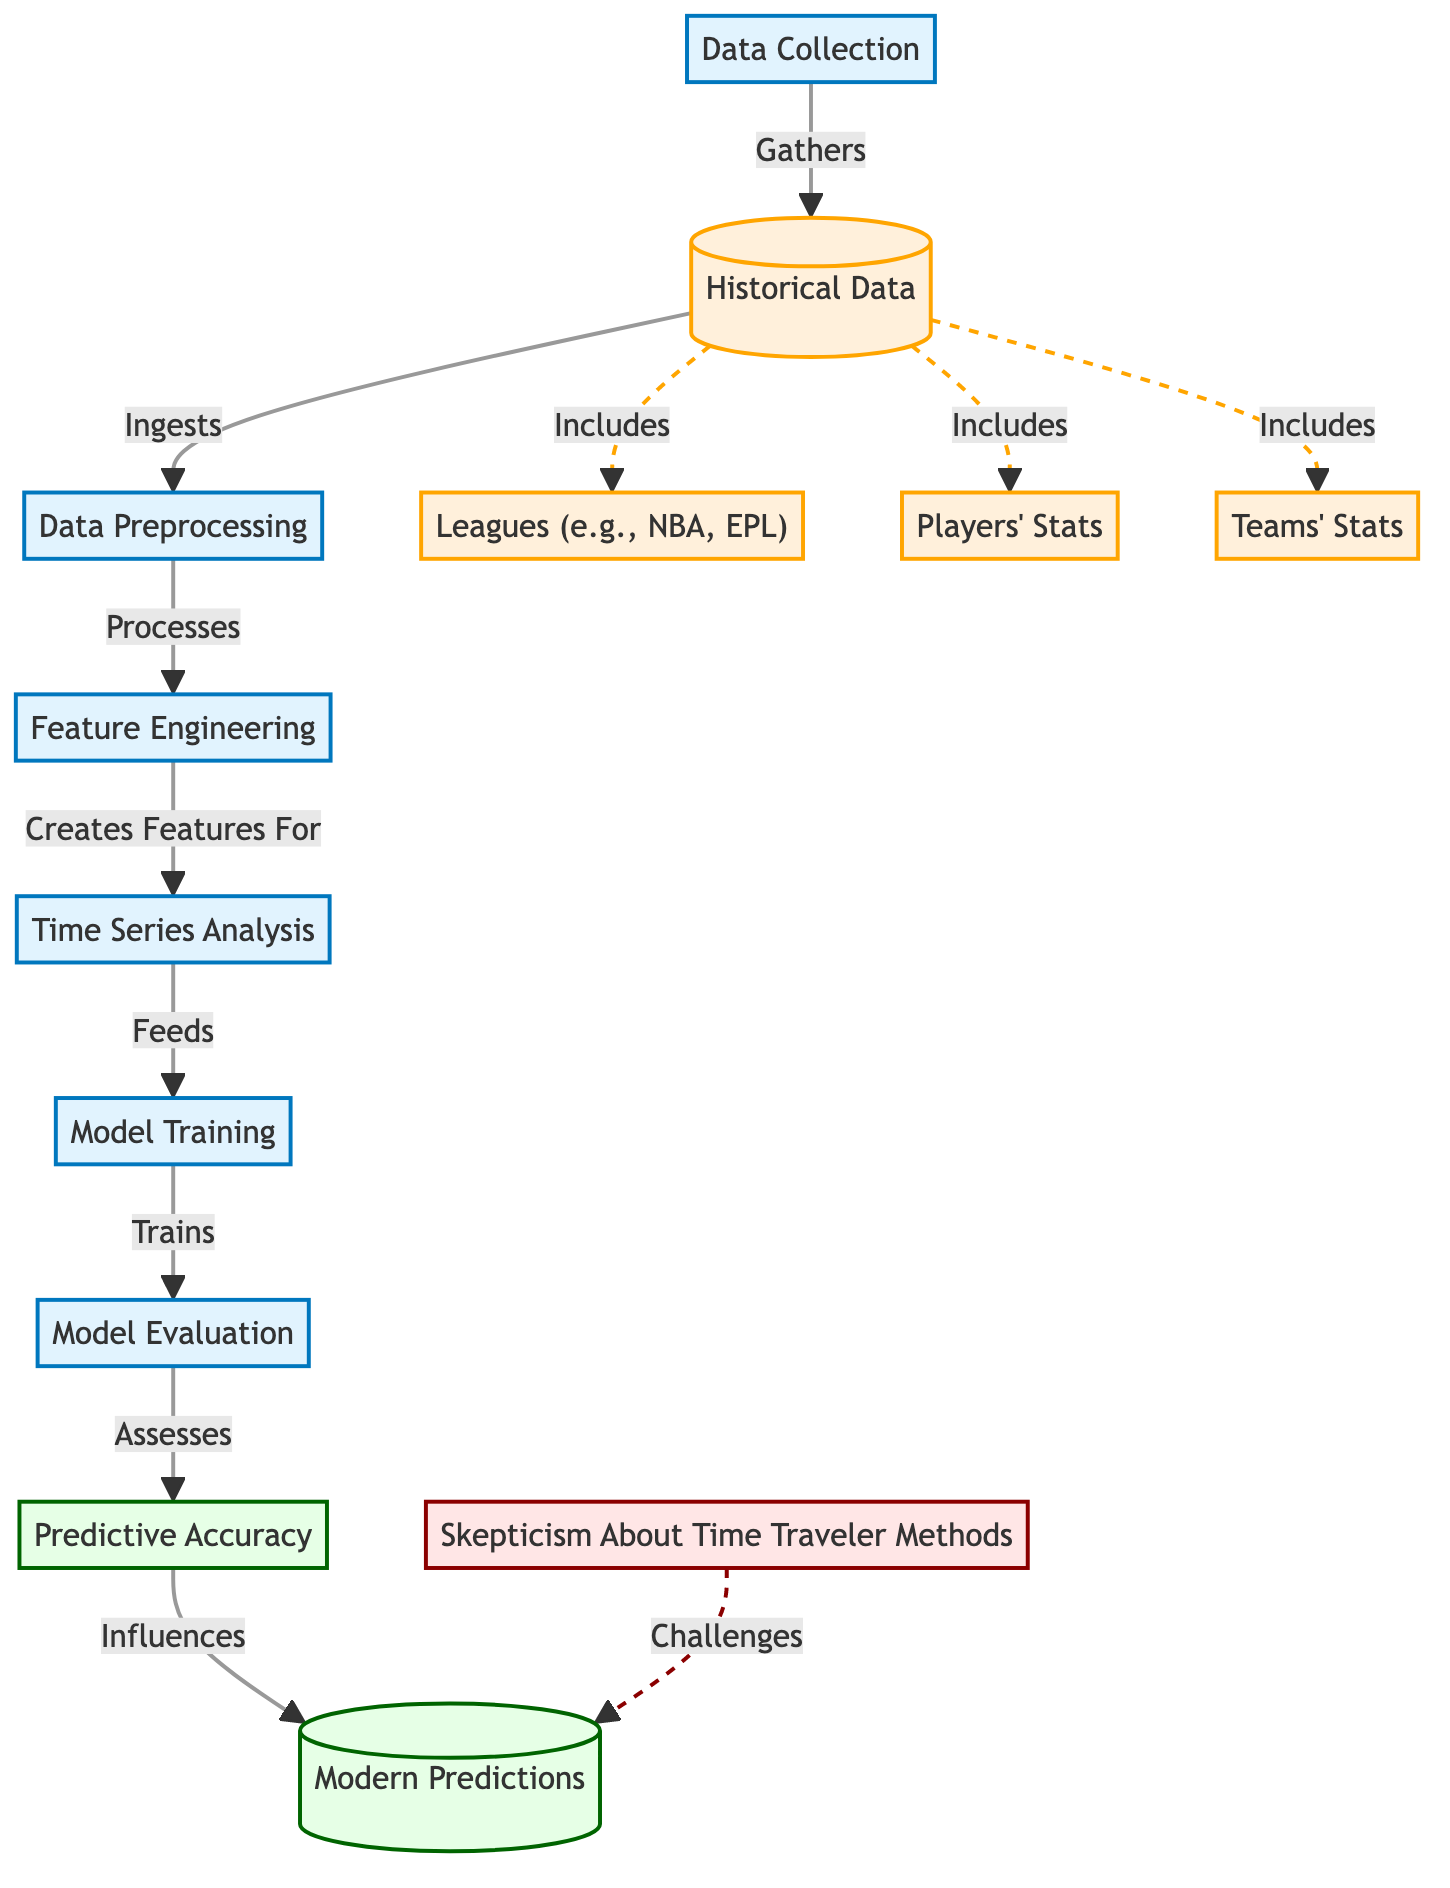What is the final outcome of the process depicted in the diagram? The diagram indicates that the final outcome is "Modern Predictions" which is the result of the entire flow process.
Answer: Modern Predictions How many distinct processes are shown in the diagram? By counting the labeled process nodes, we see that there are six distinct processes: Data Collection, Data Preprocessing, Feature Engineering, Time Series Analysis, Model Training, and Model Evaluation.
Answer: Six What type of data is ingested after Data Collection? The diagram shows that after collecting data, the next step is to ingest "Historical Data."
Answer: Historical Data What influences the "Modern Predictions" in the diagram? According to the flow, "Predictive Accuracy" is the element that influences the "Modern Predictions."
Answer: Predictive Accuracy What does the skepticism node challenge? The skepticism node labeled "Skepticism About Time Traveler Methods" shows that it challenges "Modern Predictions."
Answer: Modern Predictions Which types of statistics are included in "Historical Data"? The diagram specifies three types of statistics included in "Historical Data": Leagues, Players' Stats, and Teams' Stats.
Answer: Leagues, Players' Stats, Teams' Stats What is the role of "Feature Engineering" in the process? "Feature Engineering" creates features that are then fed into the "Time Series Analysis," making features essential for further analysis.
Answer: Creates Features For How does "Time Series Analysis" contribute to the process flow? The role of "Time Series Analysis" is to feed the information to "Model Training," indicating it is a critical step for training the predictive model.
Answer: Feeds What are the elements that comprise "Historical Data"? "Historical Data" is made up of Leagues, Players' Stats, and Teams' Stats, all contributing to the data used in the prediction process.
Answer: Leagues, Players' Stats, Teams' Stats 